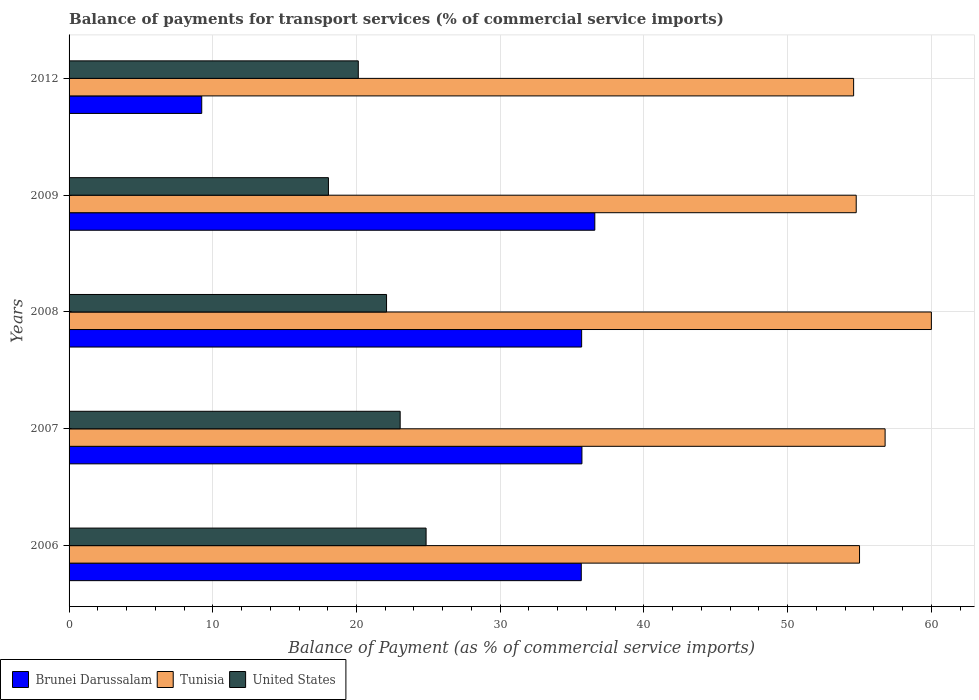How many bars are there on the 2nd tick from the top?
Provide a short and direct response. 3. In how many cases, is the number of bars for a given year not equal to the number of legend labels?
Provide a succinct answer. 0. What is the balance of payments for transport services in Brunei Darussalam in 2012?
Offer a very short reply. 9.23. Across all years, what is the maximum balance of payments for transport services in Brunei Darussalam?
Your answer should be compact. 36.58. Across all years, what is the minimum balance of payments for transport services in Brunei Darussalam?
Keep it short and to the point. 9.23. In which year was the balance of payments for transport services in Brunei Darussalam minimum?
Your response must be concise. 2012. What is the total balance of payments for transport services in Brunei Darussalam in the graph?
Provide a succinct answer. 152.81. What is the difference between the balance of payments for transport services in Tunisia in 2006 and that in 2009?
Give a very brief answer. 0.23. What is the difference between the balance of payments for transport services in Tunisia in 2009 and the balance of payments for transport services in Brunei Darussalam in 2012?
Offer a terse response. 45.54. What is the average balance of payments for transport services in Brunei Darussalam per year?
Your answer should be compact. 30.56. In the year 2009, what is the difference between the balance of payments for transport services in United States and balance of payments for transport services in Brunei Darussalam?
Give a very brief answer. -18.54. What is the ratio of the balance of payments for transport services in Tunisia in 2006 to that in 2007?
Offer a terse response. 0.97. Is the difference between the balance of payments for transport services in United States in 2006 and 2008 greater than the difference between the balance of payments for transport services in Brunei Darussalam in 2006 and 2008?
Give a very brief answer. Yes. What is the difference between the highest and the second highest balance of payments for transport services in Tunisia?
Make the answer very short. 3.22. What is the difference between the highest and the lowest balance of payments for transport services in Tunisia?
Your response must be concise. 5.41. In how many years, is the balance of payments for transport services in United States greater than the average balance of payments for transport services in United States taken over all years?
Give a very brief answer. 3. Is the sum of the balance of payments for transport services in Brunei Darussalam in 2007 and 2008 greater than the maximum balance of payments for transport services in United States across all years?
Ensure brevity in your answer.  Yes. What does the 2nd bar from the bottom in 2007 represents?
Give a very brief answer. Tunisia. Is it the case that in every year, the sum of the balance of payments for transport services in Brunei Darussalam and balance of payments for transport services in Tunisia is greater than the balance of payments for transport services in United States?
Your answer should be very brief. Yes. How many bars are there?
Make the answer very short. 15. Are all the bars in the graph horizontal?
Keep it short and to the point. Yes. What is the difference between two consecutive major ticks on the X-axis?
Provide a short and direct response. 10. Are the values on the major ticks of X-axis written in scientific E-notation?
Your response must be concise. No. Does the graph contain any zero values?
Provide a succinct answer. No. Does the graph contain grids?
Provide a succinct answer. Yes. Where does the legend appear in the graph?
Keep it short and to the point. Bottom left. How are the legend labels stacked?
Provide a succinct answer. Horizontal. What is the title of the graph?
Ensure brevity in your answer.  Balance of payments for transport services (% of commercial service imports). What is the label or title of the X-axis?
Make the answer very short. Balance of Payment (as % of commercial service imports). What is the Balance of Payment (as % of commercial service imports) in Brunei Darussalam in 2006?
Give a very brief answer. 35.64. What is the Balance of Payment (as % of commercial service imports) of Tunisia in 2006?
Make the answer very short. 55. What is the Balance of Payment (as % of commercial service imports) of United States in 2006?
Your answer should be compact. 24.84. What is the Balance of Payment (as % of commercial service imports) of Brunei Darussalam in 2007?
Provide a succinct answer. 35.69. What is the Balance of Payment (as % of commercial service imports) of Tunisia in 2007?
Offer a terse response. 56.78. What is the Balance of Payment (as % of commercial service imports) in United States in 2007?
Your answer should be very brief. 23.04. What is the Balance of Payment (as % of commercial service imports) of Brunei Darussalam in 2008?
Ensure brevity in your answer.  35.67. What is the Balance of Payment (as % of commercial service imports) of Tunisia in 2008?
Keep it short and to the point. 60. What is the Balance of Payment (as % of commercial service imports) in United States in 2008?
Your answer should be compact. 22.09. What is the Balance of Payment (as % of commercial service imports) of Brunei Darussalam in 2009?
Offer a terse response. 36.58. What is the Balance of Payment (as % of commercial service imports) of Tunisia in 2009?
Keep it short and to the point. 54.77. What is the Balance of Payment (as % of commercial service imports) in United States in 2009?
Provide a short and direct response. 18.05. What is the Balance of Payment (as % of commercial service imports) of Brunei Darussalam in 2012?
Your answer should be compact. 9.23. What is the Balance of Payment (as % of commercial service imports) in Tunisia in 2012?
Provide a succinct answer. 54.59. What is the Balance of Payment (as % of commercial service imports) of United States in 2012?
Provide a succinct answer. 20.13. Across all years, what is the maximum Balance of Payment (as % of commercial service imports) in Brunei Darussalam?
Your answer should be very brief. 36.58. Across all years, what is the maximum Balance of Payment (as % of commercial service imports) in Tunisia?
Provide a succinct answer. 60. Across all years, what is the maximum Balance of Payment (as % of commercial service imports) of United States?
Provide a succinct answer. 24.84. Across all years, what is the minimum Balance of Payment (as % of commercial service imports) in Brunei Darussalam?
Your answer should be compact. 9.23. Across all years, what is the minimum Balance of Payment (as % of commercial service imports) of Tunisia?
Give a very brief answer. 54.59. Across all years, what is the minimum Balance of Payment (as % of commercial service imports) in United States?
Offer a very short reply. 18.05. What is the total Balance of Payment (as % of commercial service imports) of Brunei Darussalam in the graph?
Offer a very short reply. 152.81. What is the total Balance of Payment (as % of commercial service imports) in Tunisia in the graph?
Offer a very short reply. 281.16. What is the total Balance of Payment (as % of commercial service imports) of United States in the graph?
Make the answer very short. 108.15. What is the difference between the Balance of Payment (as % of commercial service imports) of Brunei Darussalam in 2006 and that in 2007?
Provide a succinct answer. -0.05. What is the difference between the Balance of Payment (as % of commercial service imports) in Tunisia in 2006 and that in 2007?
Keep it short and to the point. -1.78. What is the difference between the Balance of Payment (as % of commercial service imports) of United States in 2006 and that in 2007?
Ensure brevity in your answer.  1.8. What is the difference between the Balance of Payment (as % of commercial service imports) in Brunei Darussalam in 2006 and that in 2008?
Give a very brief answer. -0.02. What is the difference between the Balance of Payment (as % of commercial service imports) in Tunisia in 2006 and that in 2008?
Offer a terse response. -5. What is the difference between the Balance of Payment (as % of commercial service imports) of United States in 2006 and that in 2008?
Your answer should be very brief. 2.75. What is the difference between the Balance of Payment (as % of commercial service imports) in Brunei Darussalam in 2006 and that in 2009?
Give a very brief answer. -0.94. What is the difference between the Balance of Payment (as % of commercial service imports) in Tunisia in 2006 and that in 2009?
Provide a short and direct response. 0.23. What is the difference between the Balance of Payment (as % of commercial service imports) of United States in 2006 and that in 2009?
Make the answer very short. 6.79. What is the difference between the Balance of Payment (as % of commercial service imports) in Brunei Darussalam in 2006 and that in 2012?
Provide a succinct answer. 26.41. What is the difference between the Balance of Payment (as % of commercial service imports) in Tunisia in 2006 and that in 2012?
Make the answer very short. 0.41. What is the difference between the Balance of Payment (as % of commercial service imports) in United States in 2006 and that in 2012?
Keep it short and to the point. 4.72. What is the difference between the Balance of Payment (as % of commercial service imports) of Brunei Darussalam in 2007 and that in 2008?
Your answer should be very brief. 0.02. What is the difference between the Balance of Payment (as % of commercial service imports) in Tunisia in 2007 and that in 2008?
Offer a very short reply. -3.22. What is the difference between the Balance of Payment (as % of commercial service imports) of United States in 2007 and that in 2008?
Provide a succinct answer. 0.95. What is the difference between the Balance of Payment (as % of commercial service imports) in Brunei Darussalam in 2007 and that in 2009?
Give a very brief answer. -0.9. What is the difference between the Balance of Payment (as % of commercial service imports) of Tunisia in 2007 and that in 2009?
Offer a very short reply. 2.01. What is the difference between the Balance of Payment (as % of commercial service imports) of United States in 2007 and that in 2009?
Give a very brief answer. 4.99. What is the difference between the Balance of Payment (as % of commercial service imports) in Brunei Darussalam in 2007 and that in 2012?
Your answer should be very brief. 26.46. What is the difference between the Balance of Payment (as % of commercial service imports) in Tunisia in 2007 and that in 2012?
Keep it short and to the point. 2.19. What is the difference between the Balance of Payment (as % of commercial service imports) in United States in 2007 and that in 2012?
Your answer should be very brief. 2.91. What is the difference between the Balance of Payment (as % of commercial service imports) in Brunei Darussalam in 2008 and that in 2009?
Make the answer very short. -0.92. What is the difference between the Balance of Payment (as % of commercial service imports) in Tunisia in 2008 and that in 2009?
Provide a short and direct response. 5.23. What is the difference between the Balance of Payment (as % of commercial service imports) in United States in 2008 and that in 2009?
Keep it short and to the point. 4.04. What is the difference between the Balance of Payment (as % of commercial service imports) in Brunei Darussalam in 2008 and that in 2012?
Offer a very short reply. 26.44. What is the difference between the Balance of Payment (as % of commercial service imports) in Tunisia in 2008 and that in 2012?
Offer a terse response. 5.41. What is the difference between the Balance of Payment (as % of commercial service imports) in United States in 2008 and that in 2012?
Your answer should be very brief. 1.97. What is the difference between the Balance of Payment (as % of commercial service imports) in Brunei Darussalam in 2009 and that in 2012?
Make the answer very short. 27.35. What is the difference between the Balance of Payment (as % of commercial service imports) of Tunisia in 2009 and that in 2012?
Provide a short and direct response. 0.18. What is the difference between the Balance of Payment (as % of commercial service imports) of United States in 2009 and that in 2012?
Keep it short and to the point. -2.08. What is the difference between the Balance of Payment (as % of commercial service imports) in Brunei Darussalam in 2006 and the Balance of Payment (as % of commercial service imports) in Tunisia in 2007?
Your answer should be very brief. -21.14. What is the difference between the Balance of Payment (as % of commercial service imports) in Brunei Darussalam in 2006 and the Balance of Payment (as % of commercial service imports) in United States in 2007?
Keep it short and to the point. 12.6. What is the difference between the Balance of Payment (as % of commercial service imports) of Tunisia in 2006 and the Balance of Payment (as % of commercial service imports) of United States in 2007?
Make the answer very short. 31.96. What is the difference between the Balance of Payment (as % of commercial service imports) in Brunei Darussalam in 2006 and the Balance of Payment (as % of commercial service imports) in Tunisia in 2008?
Your answer should be compact. -24.36. What is the difference between the Balance of Payment (as % of commercial service imports) in Brunei Darussalam in 2006 and the Balance of Payment (as % of commercial service imports) in United States in 2008?
Provide a succinct answer. 13.55. What is the difference between the Balance of Payment (as % of commercial service imports) in Tunisia in 2006 and the Balance of Payment (as % of commercial service imports) in United States in 2008?
Provide a succinct answer. 32.91. What is the difference between the Balance of Payment (as % of commercial service imports) of Brunei Darussalam in 2006 and the Balance of Payment (as % of commercial service imports) of Tunisia in 2009?
Make the answer very short. -19.13. What is the difference between the Balance of Payment (as % of commercial service imports) of Brunei Darussalam in 2006 and the Balance of Payment (as % of commercial service imports) of United States in 2009?
Give a very brief answer. 17.59. What is the difference between the Balance of Payment (as % of commercial service imports) in Tunisia in 2006 and the Balance of Payment (as % of commercial service imports) in United States in 2009?
Your answer should be compact. 36.96. What is the difference between the Balance of Payment (as % of commercial service imports) of Brunei Darussalam in 2006 and the Balance of Payment (as % of commercial service imports) of Tunisia in 2012?
Offer a terse response. -18.95. What is the difference between the Balance of Payment (as % of commercial service imports) of Brunei Darussalam in 2006 and the Balance of Payment (as % of commercial service imports) of United States in 2012?
Keep it short and to the point. 15.52. What is the difference between the Balance of Payment (as % of commercial service imports) in Tunisia in 2006 and the Balance of Payment (as % of commercial service imports) in United States in 2012?
Keep it short and to the point. 34.88. What is the difference between the Balance of Payment (as % of commercial service imports) of Brunei Darussalam in 2007 and the Balance of Payment (as % of commercial service imports) of Tunisia in 2008?
Your answer should be compact. -24.32. What is the difference between the Balance of Payment (as % of commercial service imports) of Brunei Darussalam in 2007 and the Balance of Payment (as % of commercial service imports) of United States in 2008?
Keep it short and to the point. 13.6. What is the difference between the Balance of Payment (as % of commercial service imports) in Tunisia in 2007 and the Balance of Payment (as % of commercial service imports) in United States in 2008?
Ensure brevity in your answer.  34.69. What is the difference between the Balance of Payment (as % of commercial service imports) of Brunei Darussalam in 2007 and the Balance of Payment (as % of commercial service imports) of Tunisia in 2009?
Provide a succinct answer. -19.09. What is the difference between the Balance of Payment (as % of commercial service imports) in Brunei Darussalam in 2007 and the Balance of Payment (as % of commercial service imports) in United States in 2009?
Offer a very short reply. 17.64. What is the difference between the Balance of Payment (as % of commercial service imports) in Tunisia in 2007 and the Balance of Payment (as % of commercial service imports) in United States in 2009?
Offer a terse response. 38.74. What is the difference between the Balance of Payment (as % of commercial service imports) in Brunei Darussalam in 2007 and the Balance of Payment (as % of commercial service imports) in Tunisia in 2012?
Keep it short and to the point. -18.91. What is the difference between the Balance of Payment (as % of commercial service imports) in Brunei Darussalam in 2007 and the Balance of Payment (as % of commercial service imports) in United States in 2012?
Ensure brevity in your answer.  15.56. What is the difference between the Balance of Payment (as % of commercial service imports) in Tunisia in 2007 and the Balance of Payment (as % of commercial service imports) in United States in 2012?
Offer a terse response. 36.66. What is the difference between the Balance of Payment (as % of commercial service imports) in Brunei Darussalam in 2008 and the Balance of Payment (as % of commercial service imports) in Tunisia in 2009?
Your answer should be very brief. -19.11. What is the difference between the Balance of Payment (as % of commercial service imports) in Brunei Darussalam in 2008 and the Balance of Payment (as % of commercial service imports) in United States in 2009?
Your answer should be compact. 17.62. What is the difference between the Balance of Payment (as % of commercial service imports) of Tunisia in 2008 and the Balance of Payment (as % of commercial service imports) of United States in 2009?
Your answer should be compact. 41.95. What is the difference between the Balance of Payment (as % of commercial service imports) in Brunei Darussalam in 2008 and the Balance of Payment (as % of commercial service imports) in Tunisia in 2012?
Offer a terse response. -18.93. What is the difference between the Balance of Payment (as % of commercial service imports) in Brunei Darussalam in 2008 and the Balance of Payment (as % of commercial service imports) in United States in 2012?
Provide a succinct answer. 15.54. What is the difference between the Balance of Payment (as % of commercial service imports) in Tunisia in 2008 and the Balance of Payment (as % of commercial service imports) in United States in 2012?
Make the answer very short. 39.88. What is the difference between the Balance of Payment (as % of commercial service imports) in Brunei Darussalam in 2009 and the Balance of Payment (as % of commercial service imports) in Tunisia in 2012?
Provide a short and direct response. -18.01. What is the difference between the Balance of Payment (as % of commercial service imports) in Brunei Darussalam in 2009 and the Balance of Payment (as % of commercial service imports) in United States in 2012?
Provide a short and direct response. 16.46. What is the difference between the Balance of Payment (as % of commercial service imports) of Tunisia in 2009 and the Balance of Payment (as % of commercial service imports) of United States in 2012?
Offer a terse response. 34.65. What is the average Balance of Payment (as % of commercial service imports) of Brunei Darussalam per year?
Keep it short and to the point. 30.56. What is the average Balance of Payment (as % of commercial service imports) of Tunisia per year?
Give a very brief answer. 56.23. What is the average Balance of Payment (as % of commercial service imports) of United States per year?
Offer a very short reply. 21.63. In the year 2006, what is the difference between the Balance of Payment (as % of commercial service imports) in Brunei Darussalam and Balance of Payment (as % of commercial service imports) in Tunisia?
Offer a terse response. -19.36. In the year 2006, what is the difference between the Balance of Payment (as % of commercial service imports) of Brunei Darussalam and Balance of Payment (as % of commercial service imports) of United States?
Give a very brief answer. 10.8. In the year 2006, what is the difference between the Balance of Payment (as % of commercial service imports) of Tunisia and Balance of Payment (as % of commercial service imports) of United States?
Ensure brevity in your answer.  30.16. In the year 2007, what is the difference between the Balance of Payment (as % of commercial service imports) of Brunei Darussalam and Balance of Payment (as % of commercial service imports) of Tunisia?
Offer a terse response. -21.1. In the year 2007, what is the difference between the Balance of Payment (as % of commercial service imports) of Brunei Darussalam and Balance of Payment (as % of commercial service imports) of United States?
Your answer should be compact. 12.65. In the year 2007, what is the difference between the Balance of Payment (as % of commercial service imports) of Tunisia and Balance of Payment (as % of commercial service imports) of United States?
Keep it short and to the point. 33.74. In the year 2008, what is the difference between the Balance of Payment (as % of commercial service imports) of Brunei Darussalam and Balance of Payment (as % of commercial service imports) of Tunisia?
Provide a succinct answer. -24.34. In the year 2008, what is the difference between the Balance of Payment (as % of commercial service imports) in Brunei Darussalam and Balance of Payment (as % of commercial service imports) in United States?
Offer a terse response. 13.58. In the year 2008, what is the difference between the Balance of Payment (as % of commercial service imports) of Tunisia and Balance of Payment (as % of commercial service imports) of United States?
Keep it short and to the point. 37.91. In the year 2009, what is the difference between the Balance of Payment (as % of commercial service imports) of Brunei Darussalam and Balance of Payment (as % of commercial service imports) of Tunisia?
Make the answer very short. -18.19. In the year 2009, what is the difference between the Balance of Payment (as % of commercial service imports) of Brunei Darussalam and Balance of Payment (as % of commercial service imports) of United States?
Keep it short and to the point. 18.54. In the year 2009, what is the difference between the Balance of Payment (as % of commercial service imports) in Tunisia and Balance of Payment (as % of commercial service imports) in United States?
Offer a terse response. 36.72. In the year 2012, what is the difference between the Balance of Payment (as % of commercial service imports) in Brunei Darussalam and Balance of Payment (as % of commercial service imports) in Tunisia?
Provide a succinct answer. -45.36. In the year 2012, what is the difference between the Balance of Payment (as % of commercial service imports) in Brunei Darussalam and Balance of Payment (as % of commercial service imports) in United States?
Give a very brief answer. -10.89. In the year 2012, what is the difference between the Balance of Payment (as % of commercial service imports) of Tunisia and Balance of Payment (as % of commercial service imports) of United States?
Make the answer very short. 34.47. What is the ratio of the Balance of Payment (as % of commercial service imports) of Brunei Darussalam in 2006 to that in 2007?
Give a very brief answer. 1. What is the ratio of the Balance of Payment (as % of commercial service imports) of Tunisia in 2006 to that in 2007?
Your answer should be compact. 0.97. What is the ratio of the Balance of Payment (as % of commercial service imports) in United States in 2006 to that in 2007?
Provide a succinct answer. 1.08. What is the ratio of the Balance of Payment (as % of commercial service imports) of Brunei Darussalam in 2006 to that in 2008?
Offer a terse response. 1. What is the ratio of the Balance of Payment (as % of commercial service imports) in United States in 2006 to that in 2008?
Make the answer very short. 1.12. What is the ratio of the Balance of Payment (as % of commercial service imports) of Brunei Darussalam in 2006 to that in 2009?
Provide a succinct answer. 0.97. What is the ratio of the Balance of Payment (as % of commercial service imports) of Tunisia in 2006 to that in 2009?
Your answer should be very brief. 1. What is the ratio of the Balance of Payment (as % of commercial service imports) in United States in 2006 to that in 2009?
Your answer should be very brief. 1.38. What is the ratio of the Balance of Payment (as % of commercial service imports) of Brunei Darussalam in 2006 to that in 2012?
Make the answer very short. 3.86. What is the ratio of the Balance of Payment (as % of commercial service imports) in Tunisia in 2006 to that in 2012?
Provide a succinct answer. 1.01. What is the ratio of the Balance of Payment (as % of commercial service imports) in United States in 2006 to that in 2012?
Offer a very short reply. 1.23. What is the ratio of the Balance of Payment (as % of commercial service imports) in Tunisia in 2007 to that in 2008?
Offer a very short reply. 0.95. What is the ratio of the Balance of Payment (as % of commercial service imports) of United States in 2007 to that in 2008?
Offer a terse response. 1.04. What is the ratio of the Balance of Payment (as % of commercial service imports) in Brunei Darussalam in 2007 to that in 2009?
Your answer should be compact. 0.98. What is the ratio of the Balance of Payment (as % of commercial service imports) in Tunisia in 2007 to that in 2009?
Provide a succinct answer. 1.04. What is the ratio of the Balance of Payment (as % of commercial service imports) of United States in 2007 to that in 2009?
Keep it short and to the point. 1.28. What is the ratio of the Balance of Payment (as % of commercial service imports) in Brunei Darussalam in 2007 to that in 2012?
Your response must be concise. 3.87. What is the ratio of the Balance of Payment (as % of commercial service imports) in Tunisia in 2007 to that in 2012?
Ensure brevity in your answer.  1.04. What is the ratio of the Balance of Payment (as % of commercial service imports) of United States in 2007 to that in 2012?
Your answer should be compact. 1.14. What is the ratio of the Balance of Payment (as % of commercial service imports) of Brunei Darussalam in 2008 to that in 2009?
Make the answer very short. 0.97. What is the ratio of the Balance of Payment (as % of commercial service imports) in Tunisia in 2008 to that in 2009?
Keep it short and to the point. 1.1. What is the ratio of the Balance of Payment (as % of commercial service imports) of United States in 2008 to that in 2009?
Give a very brief answer. 1.22. What is the ratio of the Balance of Payment (as % of commercial service imports) of Brunei Darussalam in 2008 to that in 2012?
Provide a succinct answer. 3.86. What is the ratio of the Balance of Payment (as % of commercial service imports) in Tunisia in 2008 to that in 2012?
Provide a short and direct response. 1.1. What is the ratio of the Balance of Payment (as % of commercial service imports) in United States in 2008 to that in 2012?
Make the answer very short. 1.1. What is the ratio of the Balance of Payment (as % of commercial service imports) in Brunei Darussalam in 2009 to that in 2012?
Offer a terse response. 3.96. What is the ratio of the Balance of Payment (as % of commercial service imports) in United States in 2009 to that in 2012?
Your answer should be compact. 0.9. What is the difference between the highest and the second highest Balance of Payment (as % of commercial service imports) of Brunei Darussalam?
Keep it short and to the point. 0.9. What is the difference between the highest and the second highest Balance of Payment (as % of commercial service imports) in Tunisia?
Your answer should be compact. 3.22. What is the difference between the highest and the second highest Balance of Payment (as % of commercial service imports) of United States?
Provide a succinct answer. 1.8. What is the difference between the highest and the lowest Balance of Payment (as % of commercial service imports) in Brunei Darussalam?
Provide a short and direct response. 27.35. What is the difference between the highest and the lowest Balance of Payment (as % of commercial service imports) of Tunisia?
Give a very brief answer. 5.41. What is the difference between the highest and the lowest Balance of Payment (as % of commercial service imports) of United States?
Provide a succinct answer. 6.79. 